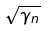Convert formula to latex. <formula><loc_0><loc_0><loc_500><loc_500>\sqrt { \gamma _ { n } }</formula> 